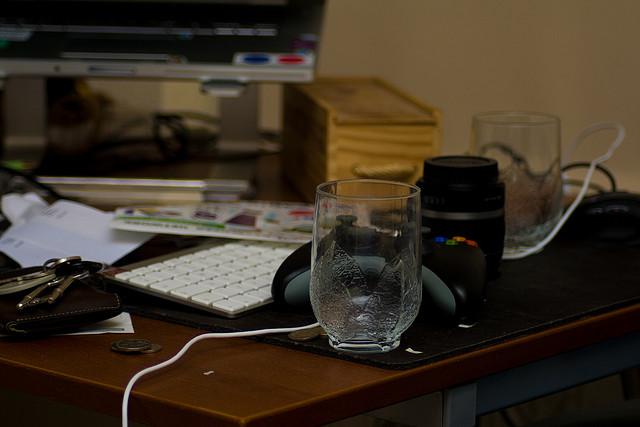Is there any liquid in the glass?
Short answer required. No. Is the keyboard being used?
Concise answer only. No. How many glasses are there?
Answer briefly. 2. Are some dishes washed?
Answer briefly. No. What color is the tray?
Give a very brief answer. Black. How many glasses is seen?
Quick response, please. 2. Are there keys in the picture?
Keep it brief. Yes. What is in the cup?
Give a very brief answer. Nothing. Is the glass empty?
Concise answer only. Yes. What is the beverage in the mug?
Short answer required. Water. What color is dominant?
Answer briefly. Brown. 